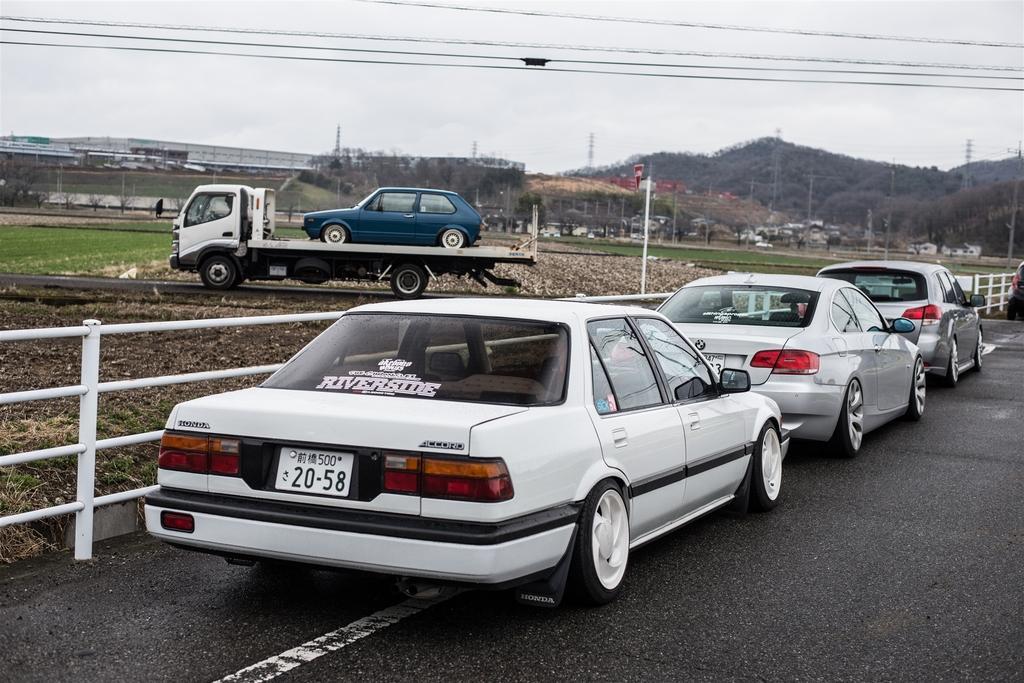Could you give a brief overview of what you see in this image? In the image there are few cars on the road beside a fence and on the left side there is a truck going on road carrying a car and behind it there is grass land with trees all over the place and there is a hill in the background and above its sky. 